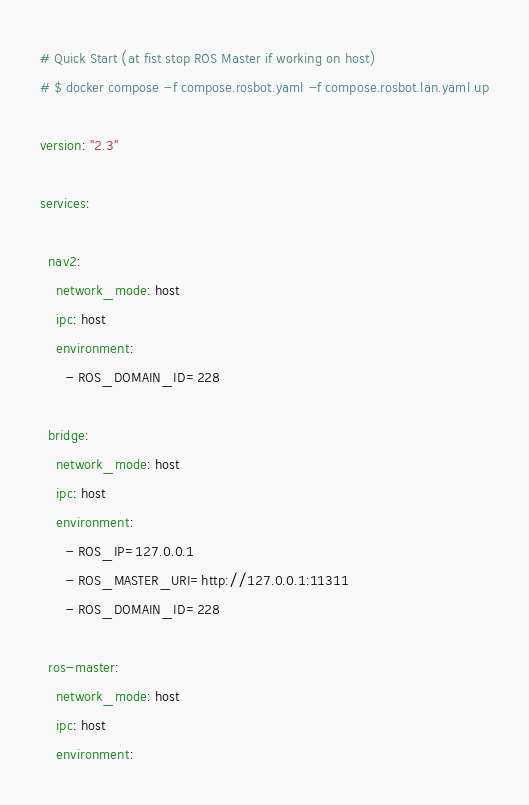<code> <loc_0><loc_0><loc_500><loc_500><_YAML_># Quick Start (at fist stop ROS Master if working on host)
# $ docker compose -f compose.rosbot.yaml -f compose.rosbot.lan.yaml up

version: "2.3"

services:

  nav2:
    network_mode: host
    ipc: host
    environment:
      - ROS_DOMAIN_ID=228

  bridge:
    network_mode: host
    ipc: host
    environment:
      - ROS_IP=127.0.0.1
      - ROS_MASTER_URI=http://127.0.0.1:11311
      - ROS_DOMAIN_ID=228

  ros-master:
    network_mode: host
    ipc: host
    environment:</code> 